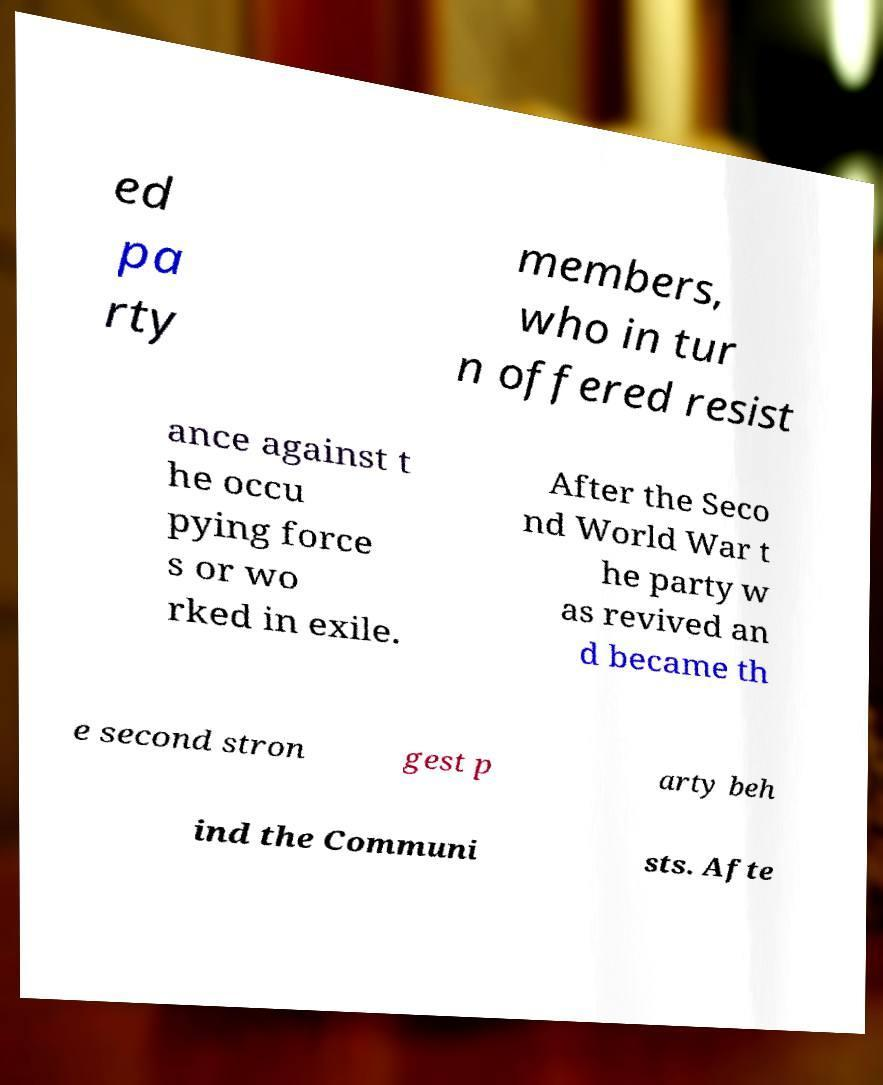Can you accurately transcribe the text from the provided image for me? ed pa rty members, who in tur n offered resist ance against t he occu pying force s or wo rked in exile. After the Seco nd World War t he party w as revived an d became th e second stron gest p arty beh ind the Communi sts. Afte 